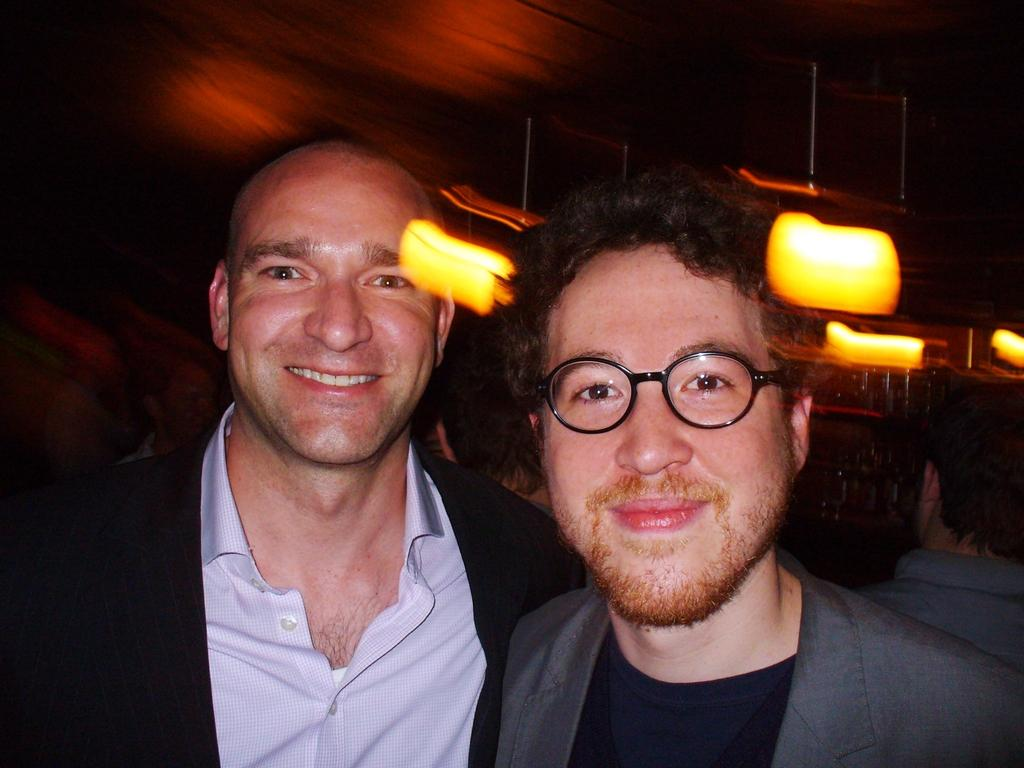How many men are in the image? There are two men in the image. What are the men doing in the image? The men are smiling in the front of the image. Can you describe the appearance of one of the men? One man on the right side is wearing spectacles. What can be seen in the background of the image? There are lights visible in the background of the image. How would you describe the background of the image? The background appears blurry. What type of popcorn is being served in the cellar in the image? There is no popcorn or cellar present in the image. 